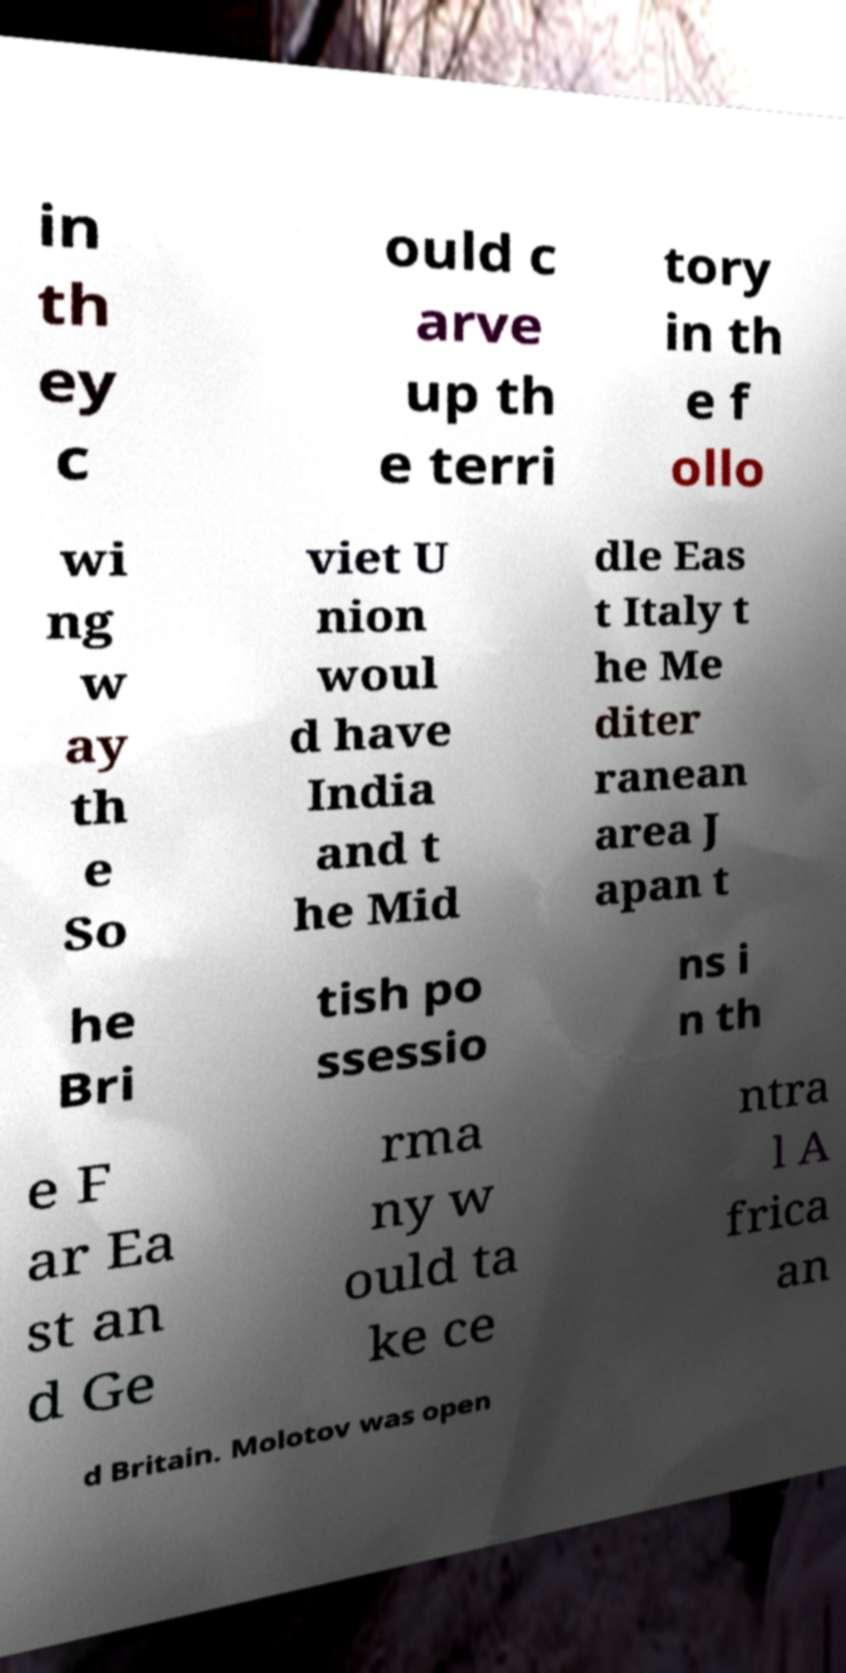For documentation purposes, I need the text within this image transcribed. Could you provide that? in th ey c ould c arve up th e terri tory in th e f ollo wi ng w ay th e So viet U nion woul d have India and t he Mid dle Eas t Italy t he Me diter ranean area J apan t he Bri tish po ssessio ns i n th e F ar Ea st an d Ge rma ny w ould ta ke ce ntra l A frica an d Britain. Molotov was open 